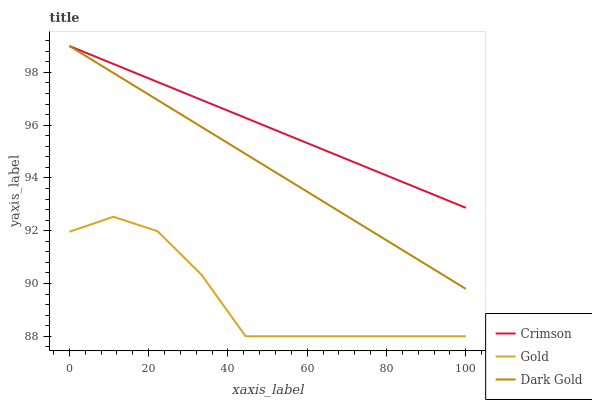Does Gold have the minimum area under the curve?
Answer yes or no. Yes. Does Crimson have the maximum area under the curve?
Answer yes or no. Yes. Does Dark Gold have the minimum area under the curve?
Answer yes or no. No. Does Dark Gold have the maximum area under the curve?
Answer yes or no. No. Is Crimson the smoothest?
Answer yes or no. Yes. Is Gold the roughest?
Answer yes or no. Yes. Is Dark Gold the smoothest?
Answer yes or no. No. Is Dark Gold the roughest?
Answer yes or no. No. Does Gold have the lowest value?
Answer yes or no. Yes. Does Dark Gold have the lowest value?
Answer yes or no. No. Does Dark Gold have the highest value?
Answer yes or no. Yes. Does Gold have the highest value?
Answer yes or no. No. Is Gold less than Crimson?
Answer yes or no. Yes. Is Dark Gold greater than Gold?
Answer yes or no. Yes. Does Dark Gold intersect Crimson?
Answer yes or no. Yes. Is Dark Gold less than Crimson?
Answer yes or no. No. Is Dark Gold greater than Crimson?
Answer yes or no. No. Does Gold intersect Crimson?
Answer yes or no. No. 